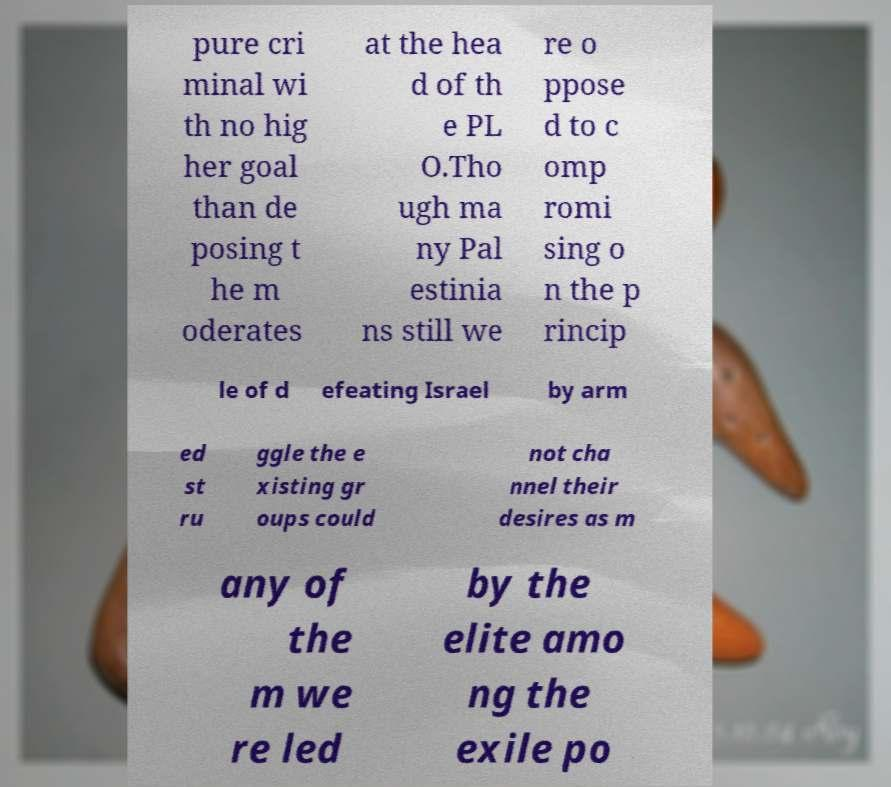Can you accurately transcribe the text from the provided image for me? pure cri minal wi th no hig her goal than de posing t he m oderates at the hea d of th e PL O.Tho ugh ma ny Pal estinia ns still we re o ppose d to c omp romi sing o n the p rincip le of d efeating Israel by arm ed st ru ggle the e xisting gr oups could not cha nnel their desires as m any of the m we re led by the elite amo ng the exile po 